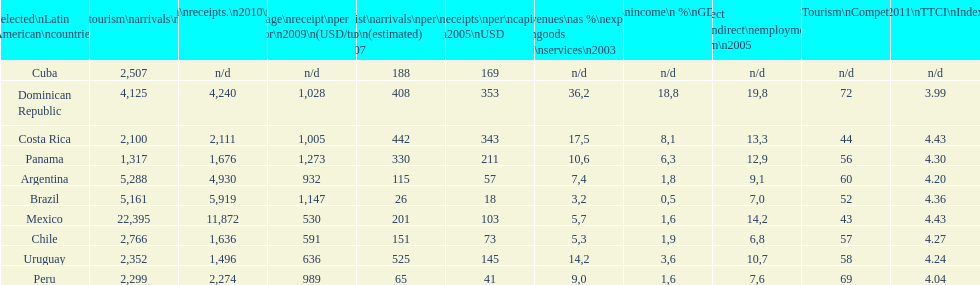What country had the most receipts per capita in 2005? Dominican Republic. 